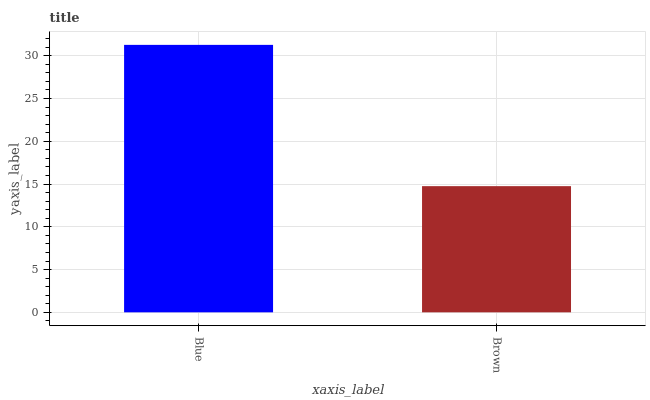Is Brown the minimum?
Answer yes or no. Yes. Is Blue the maximum?
Answer yes or no. Yes. Is Brown the maximum?
Answer yes or no. No. Is Blue greater than Brown?
Answer yes or no. Yes. Is Brown less than Blue?
Answer yes or no. Yes. Is Brown greater than Blue?
Answer yes or no. No. Is Blue less than Brown?
Answer yes or no. No. Is Blue the high median?
Answer yes or no. Yes. Is Brown the low median?
Answer yes or no. Yes. Is Brown the high median?
Answer yes or no. No. Is Blue the low median?
Answer yes or no. No. 